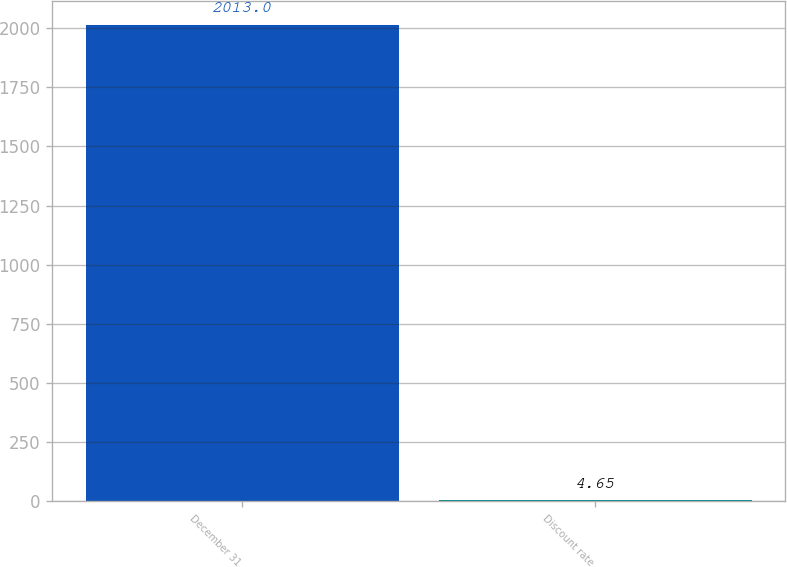Convert chart. <chart><loc_0><loc_0><loc_500><loc_500><bar_chart><fcel>December 31<fcel>Discount rate<nl><fcel>2013<fcel>4.65<nl></chart> 